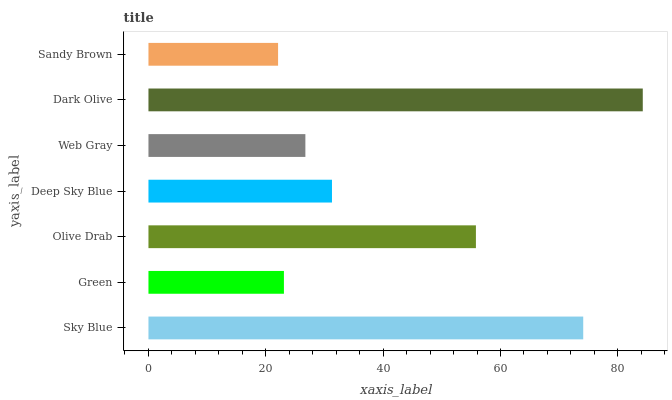Is Sandy Brown the minimum?
Answer yes or no. Yes. Is Dark Olive the maximum?
Answer yes or no. Yes. Is Green the minimum?
Answer yes or no. No. Is Green the maximum?
Answer yes or no. No. Is Sky Blue greater than Green?
Answer yes or no. Yes. Is Green less than Sky Blue?
Answer yes or no. Yes. Is Green greater than Sky Blue?
Answer yes or no. No. Is Sky Blue less than Green?
Answer yes or no. No. Is Deep Sky Blue the high median?
Answer yes or no. Yes. Is Deep Sky Blue the low median?
Answer yes or no. Yes. Is Olive Drab the high median?
Answer yes or no. No. Is Olive Drab the low median?
Answer yes or no. No. 